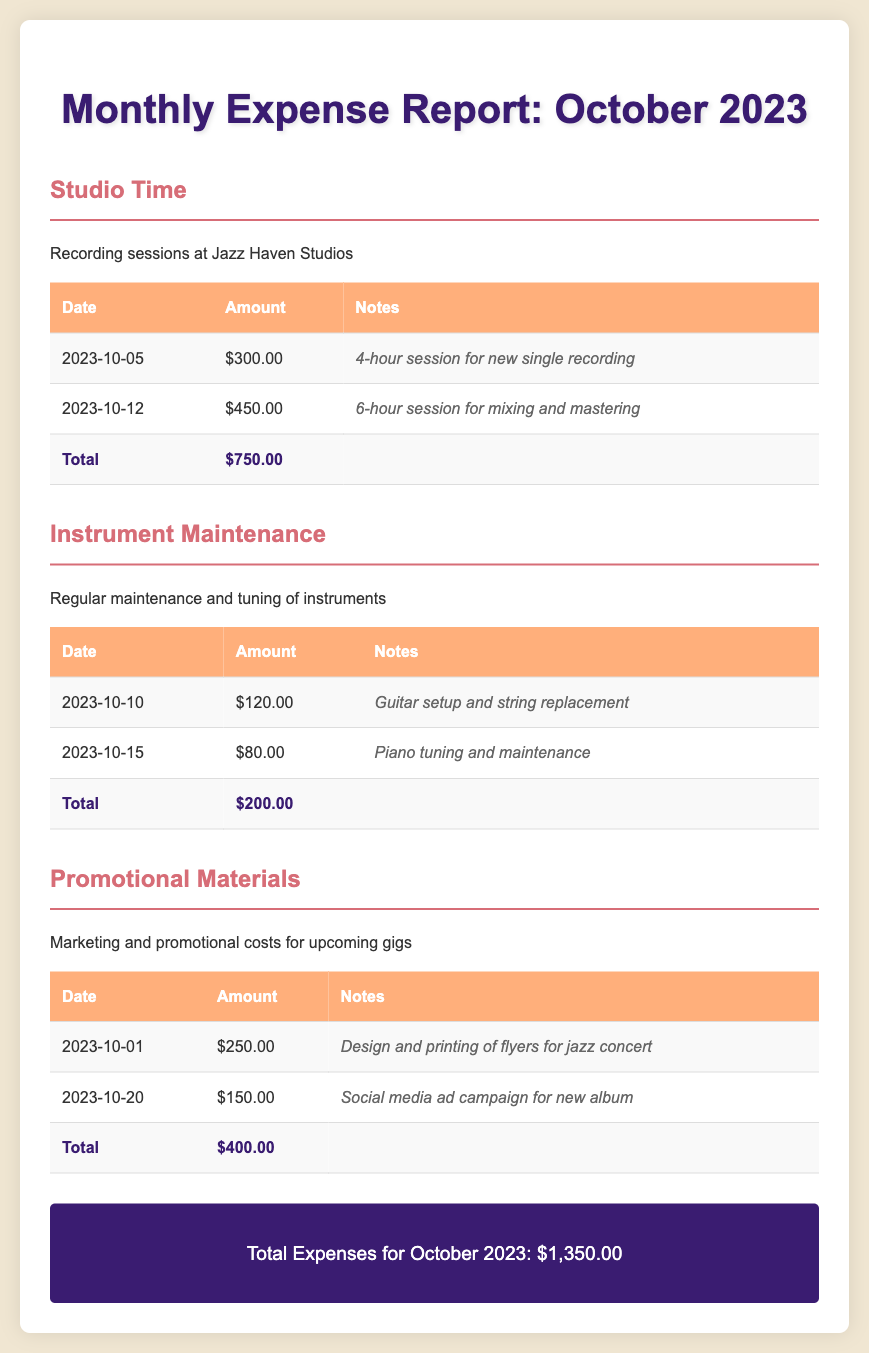what was the date of the first studio session? The first studio session took place on October 5, 2023.
Answer: October 5, 2023 how much was spent on instrument maintenance? The total spent on instrument maintenance is listed under that category in the report, which is $200.00.
Answer: $200.00 what is the cost of the social media ad campaign? The cost for the social media ad campaign is detailed in the promotional materials section, which states $150.00.
Answer: $150.00 what was the total amount spent on studio time? The total for studio time is calculated at the end of the studio time section, amounting to $750.00.
Answer: $750.00 which type of expense had the highest amount? By comparing the totals of all categories, studio time at $750.00 is the highest.
Answer: Studio Time what is the total expense for October 2023? The total expense is stated clearly at the end of the report, summing all categories to $1,350.00.
Answer: $1,350.00 how many hours were spent in the studio for the first recording session? The document notes that four hours were spent during the first recording session.
Answer: 4 hours when was the piano tuning and maintenance performed? The piano tuning and maintenance took place on October 15, 2023, as per the document.
Answer: October 15, 2023 what was the purpose of the flyers that were printed? The printed flyers were designed for a jazz concert, as noted in the promotional materials section.
Answer: Jazz concert 